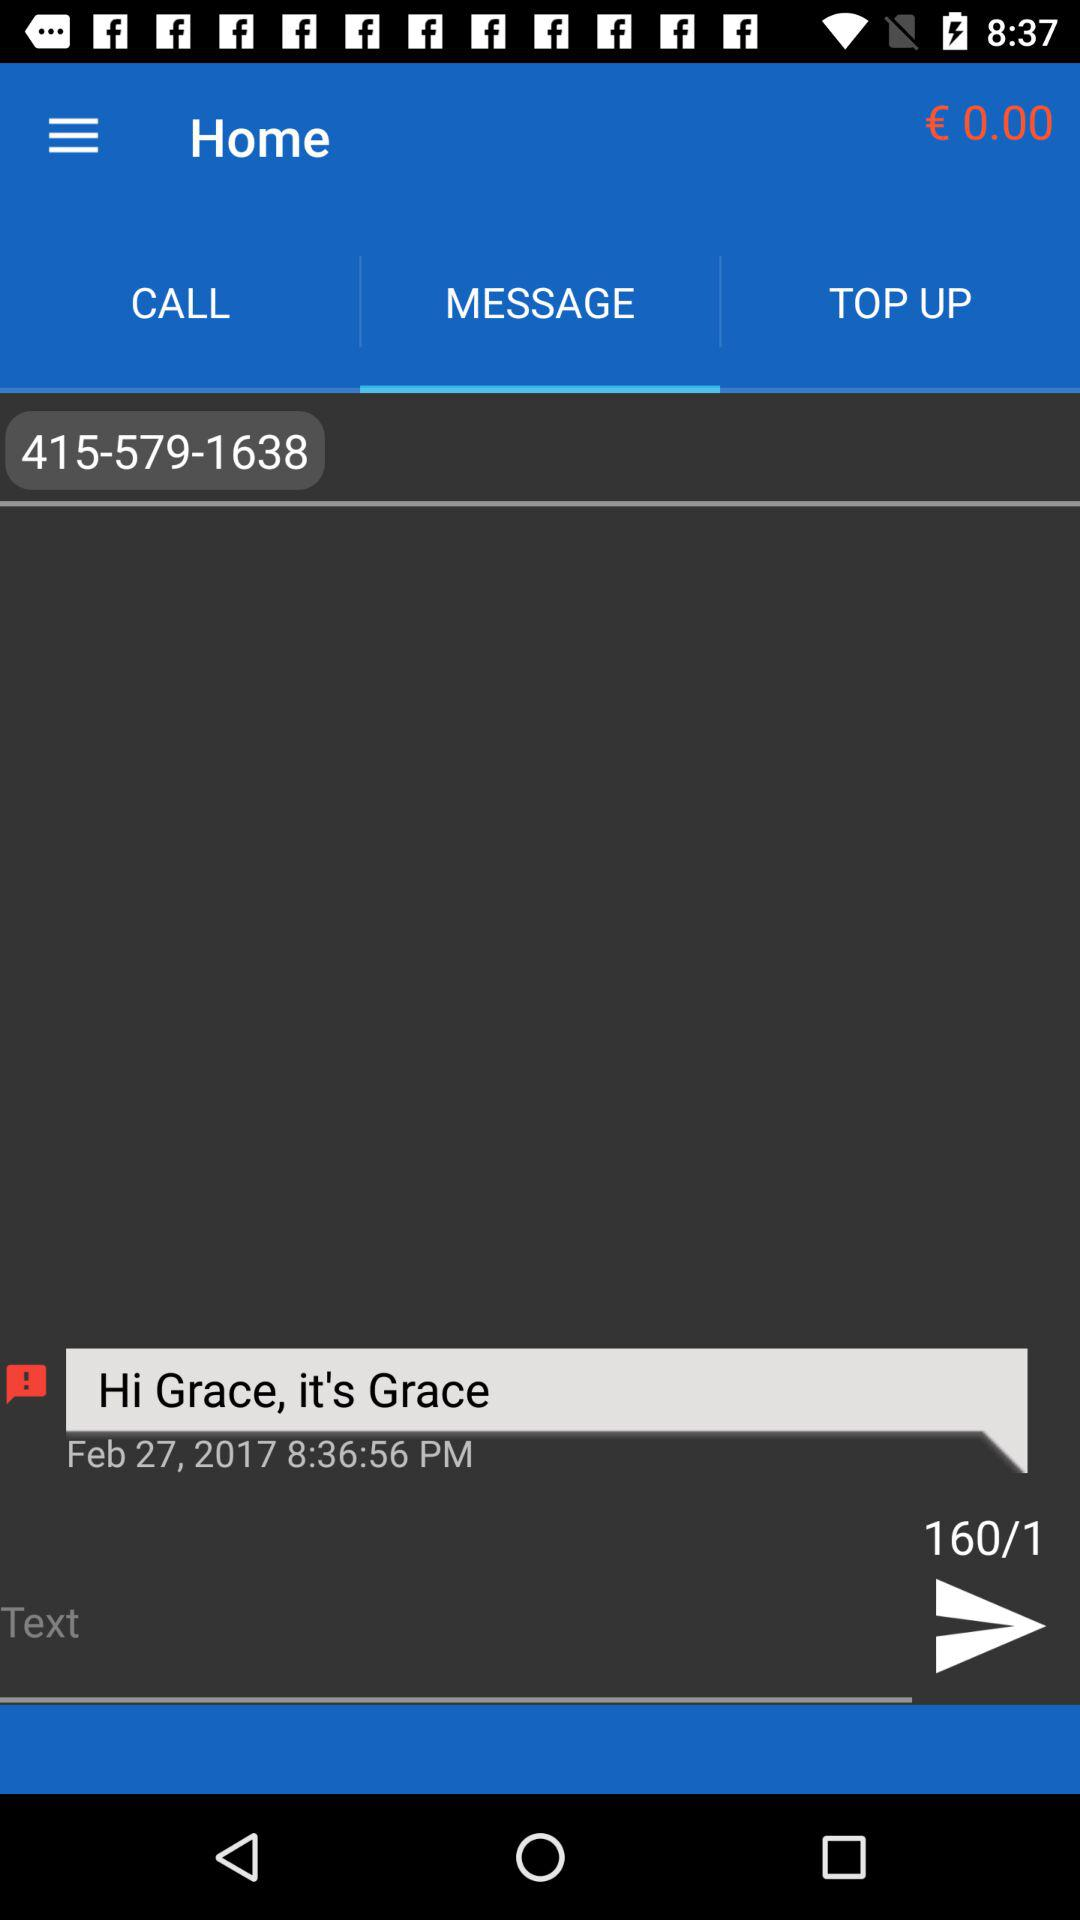At what time was the message sent? The message was sent at 8:36:56 p.m. 